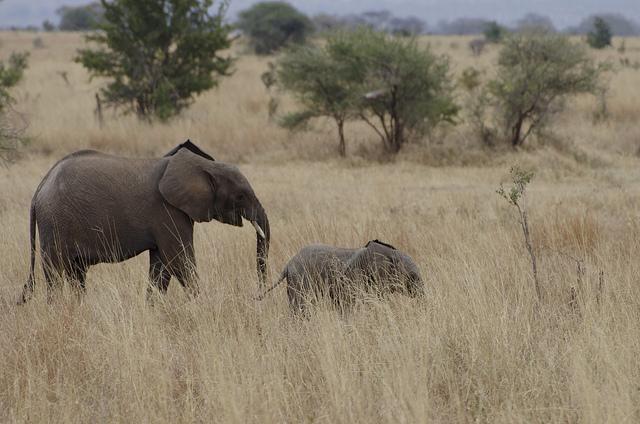How many elephants are in this photo?
Keep it brief. 2. How many baby elephants do you see?
Concise answer only. 1. How many juvenile elephants are in the picture?
Write a very short answer. 1. Are the elephants young?
Concise answer only. Yes. 